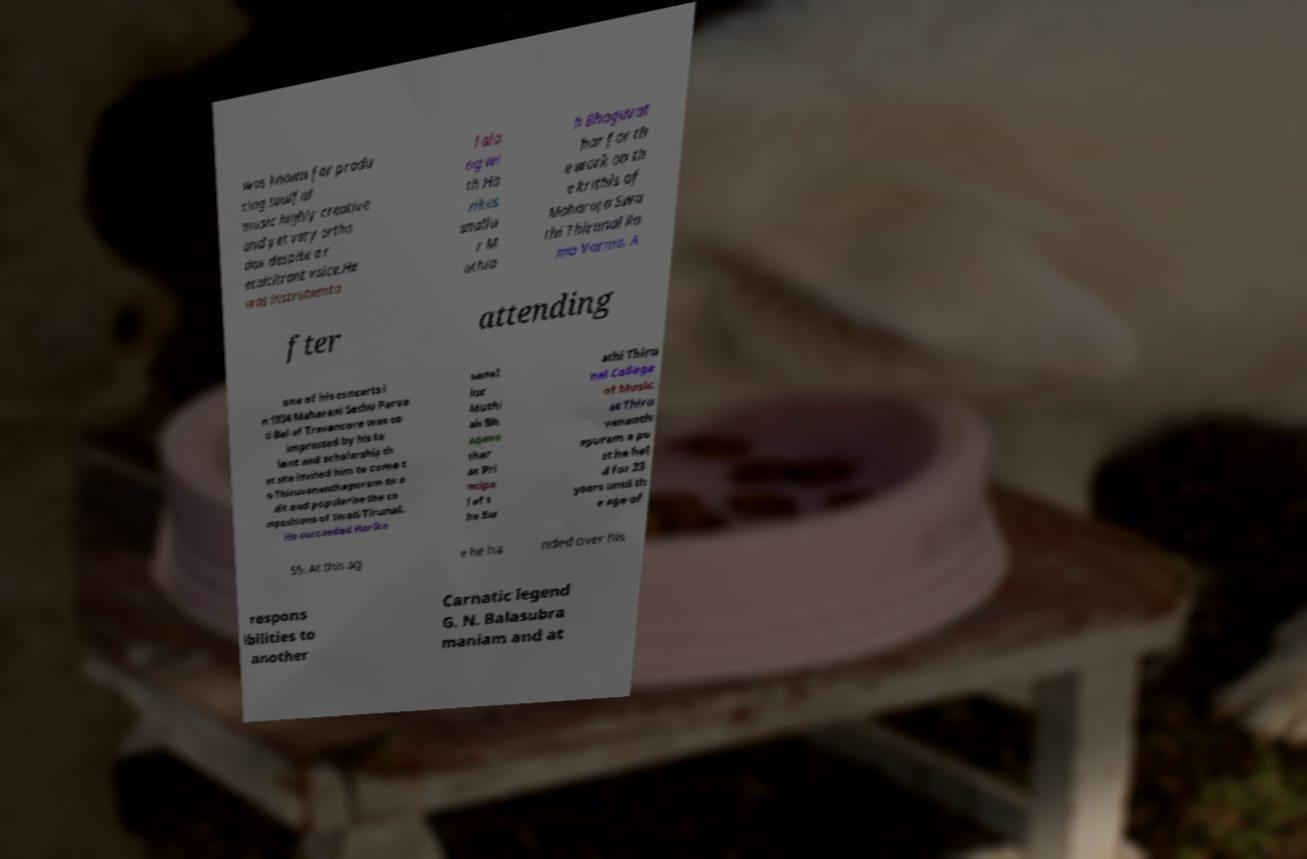Please identify and transcribe the text found in this image. was known for produ cing soulful music highly creative and yet very ortho dox despite a r ecalcitrant voice.He was instrumenta l alo ng wi th Ha rikes anallu r M uthia h Bhagavat har for th e work on th e krithis of Maharaja Swa thi Thirunal Ra ma Varma. A fter attending one of his concerts i n 1934 Maharani Sethu Parva ti Bai of Travancore was so impressed by his ta lent and scholarship th at she invited him to come t o Thiruvananthapuram to e dit and popularise the co mpositions of Swati Tirunal. He succeeded Harike sanal lur Muthi ah Bh agava thar as Pri ncipa l of t he Sw athi Thiru nal College of Music at Thiru vananth apuram a po st he hel d for 23 years until th e age of 55. At this ag e he ha nded over his respons ibilities to another Carnatic legend G. N. Balasubra maniam and at 